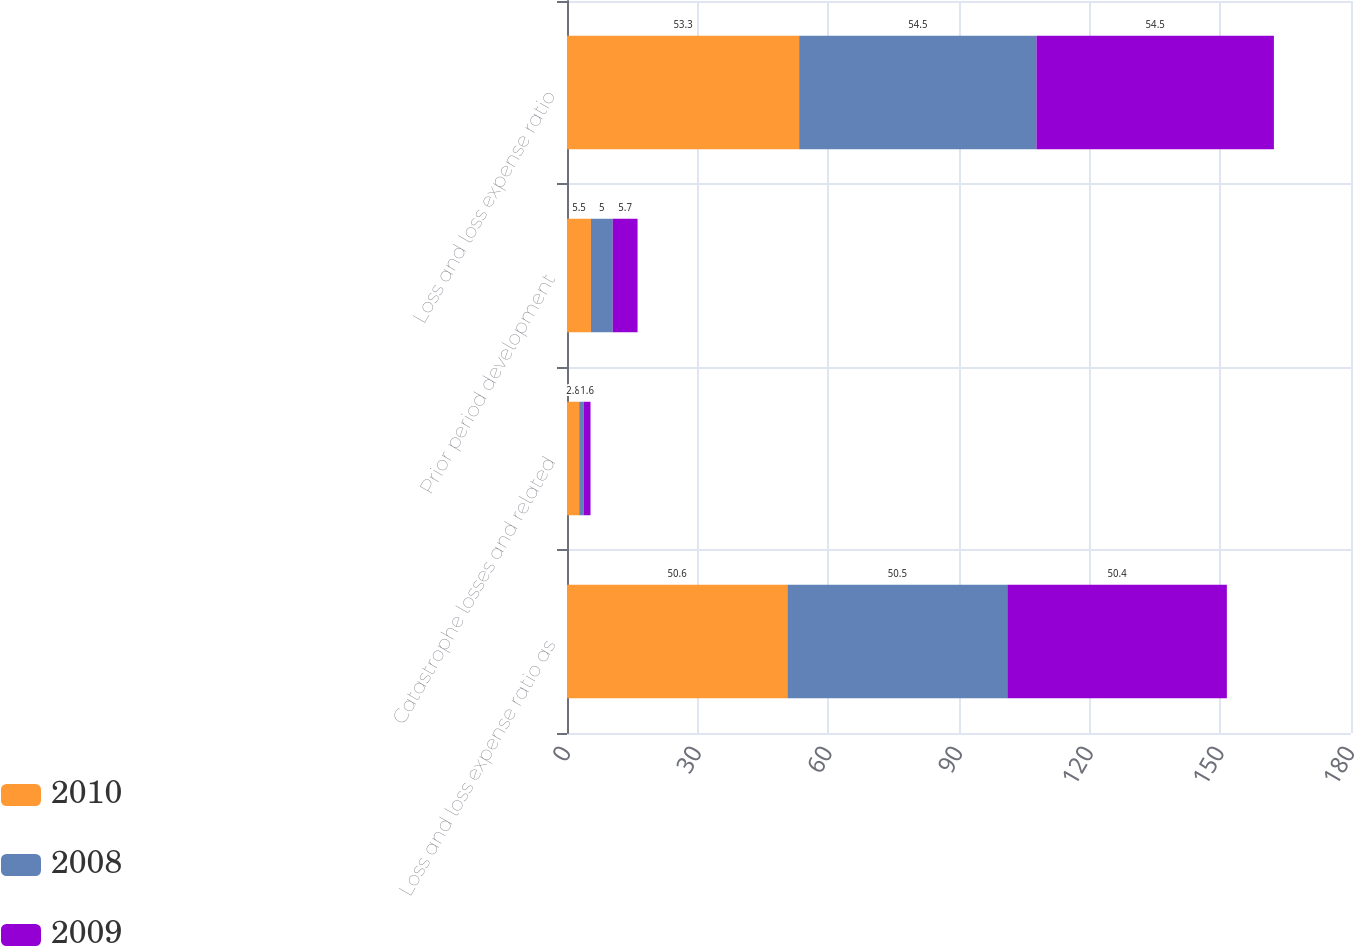Convert chart. <chart><loc_0><loc_0><loc_500><loc_500><stacked_bar_chart><ecel><fcel>Loss and loss expense ratio as<fcel>Catastrophe losses and related<fcel>Prior period development<fcel>Loss and loss expense ratio<nl><fcel>2010<fcel>50.6<fcel>2.8<fcel>5.5<fcel>53.3<nl><fcel>2008<fcel>50.5<fcel>1<fcel>5<fcel>54.5<nl><fcel>2009<fcel>50.4<fcel>1.6<fcel>5.7<fcel>54.5<nl></chart> 